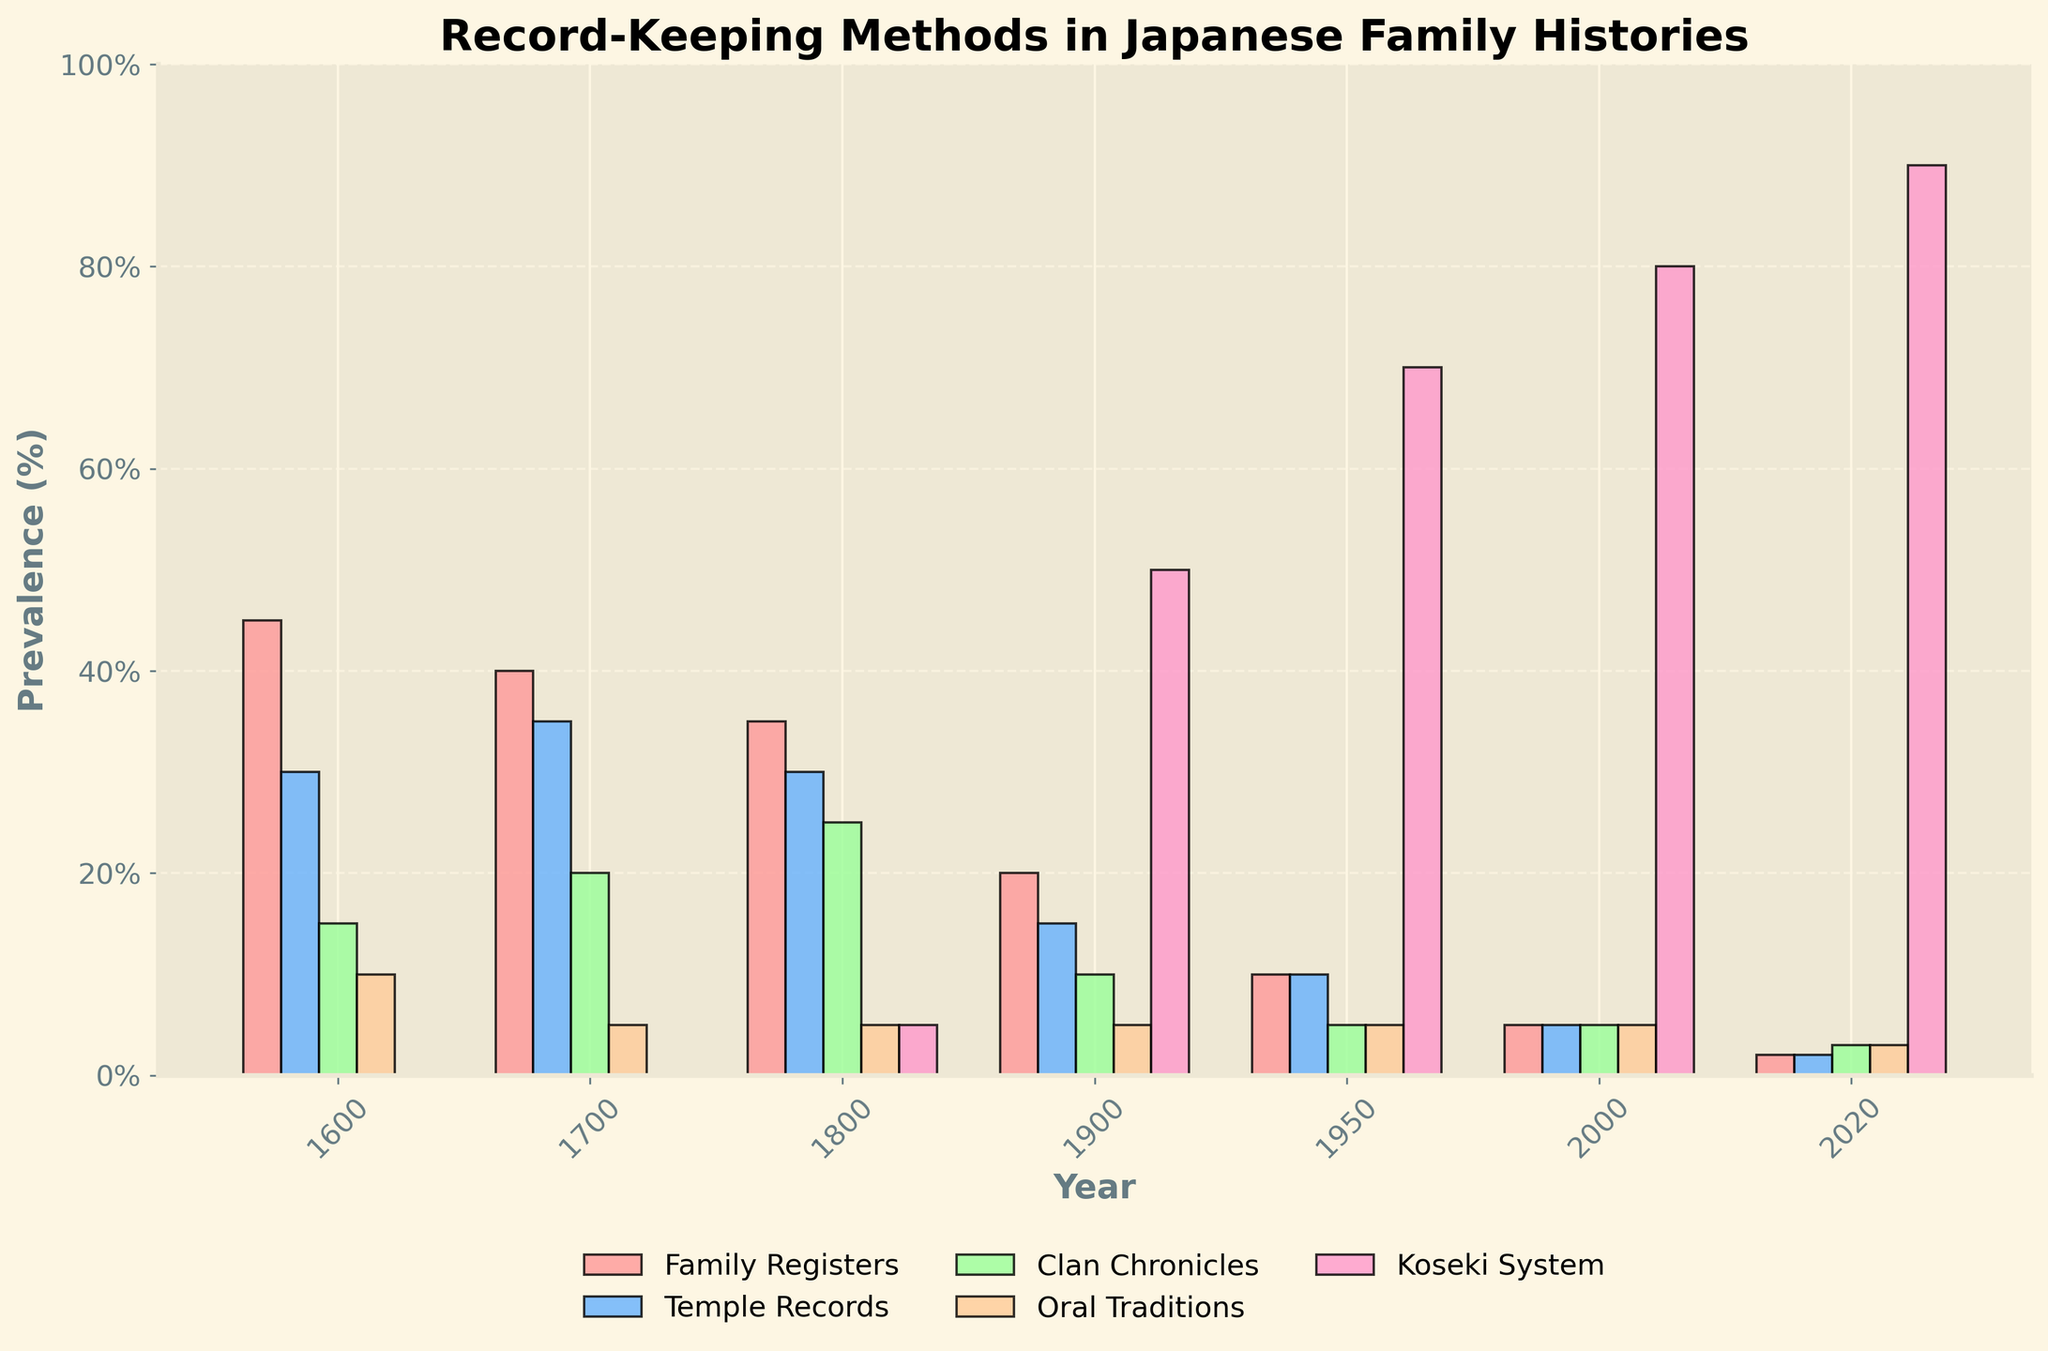What method was most prevalent in 2020? By looking at the bar heights in 2020, we find the "Koseki System" bar is the highest, indicating it was the most prevalent.
Answer: Koseki System How did the prevalence of "Oral Traditions" change from 1600 to 2020? In 1600, the prevalence was 10%, and in 2020, it dropped to 3%. By subtracting 3% from 10%, we find a decrease of 7%.
Answer: 7% Which years had the least prevalence of "Family Registers"? From the graph, the "Family Registers" bar appears shortest in 2020, at approximately 2%.
Answer: 2020 What is the sum of the prevalence percentages for "Temple Records" in 1700 and "Clan Chronicles" in 1800? "Temple Records" in 1700 is 35% and "Clan Chronicles" in 1800 is 25%. Adding these values: 35% + 25% = 60%.
Answer: 60% In which year did the "Koseki System" first appear, and what was its prevalence in that year? The "Koseki System" first appears in 1800 with a prevalence of 5%.
Answer: 1800, 5% Compare the prevalence of "Clan Chronicles" and "Oral Traditions" in 1900. Which was higher? In 1900, "Clan Chronicles" had a prevalence of 10%, while "Oral Traditions" stood at 5%. Therefore, "Clan Chronicles" was higher.
Answer: Clan Chronicles What pattern do you observe in the prevalence of "Family Registers" from 1600 to 2020? "Family Registers" show a consistent decline over the years from 45% in 1600 to 2% in 2020.
Answer: Decline How much did the prevalence of the "Koseki System" increase from 1900 to 2020? The "Koseki System" was 50% in 1900 and increased to 90% in 2020. The difference is 90% - 50% = 40%.
Answer: 40% Identify the year with an equal prevalence of "Temple Records" and "Family Registers". Both "Temple Records" and "Family Registers" had a prevalence of 10% in 1950.
Answer: 1950 